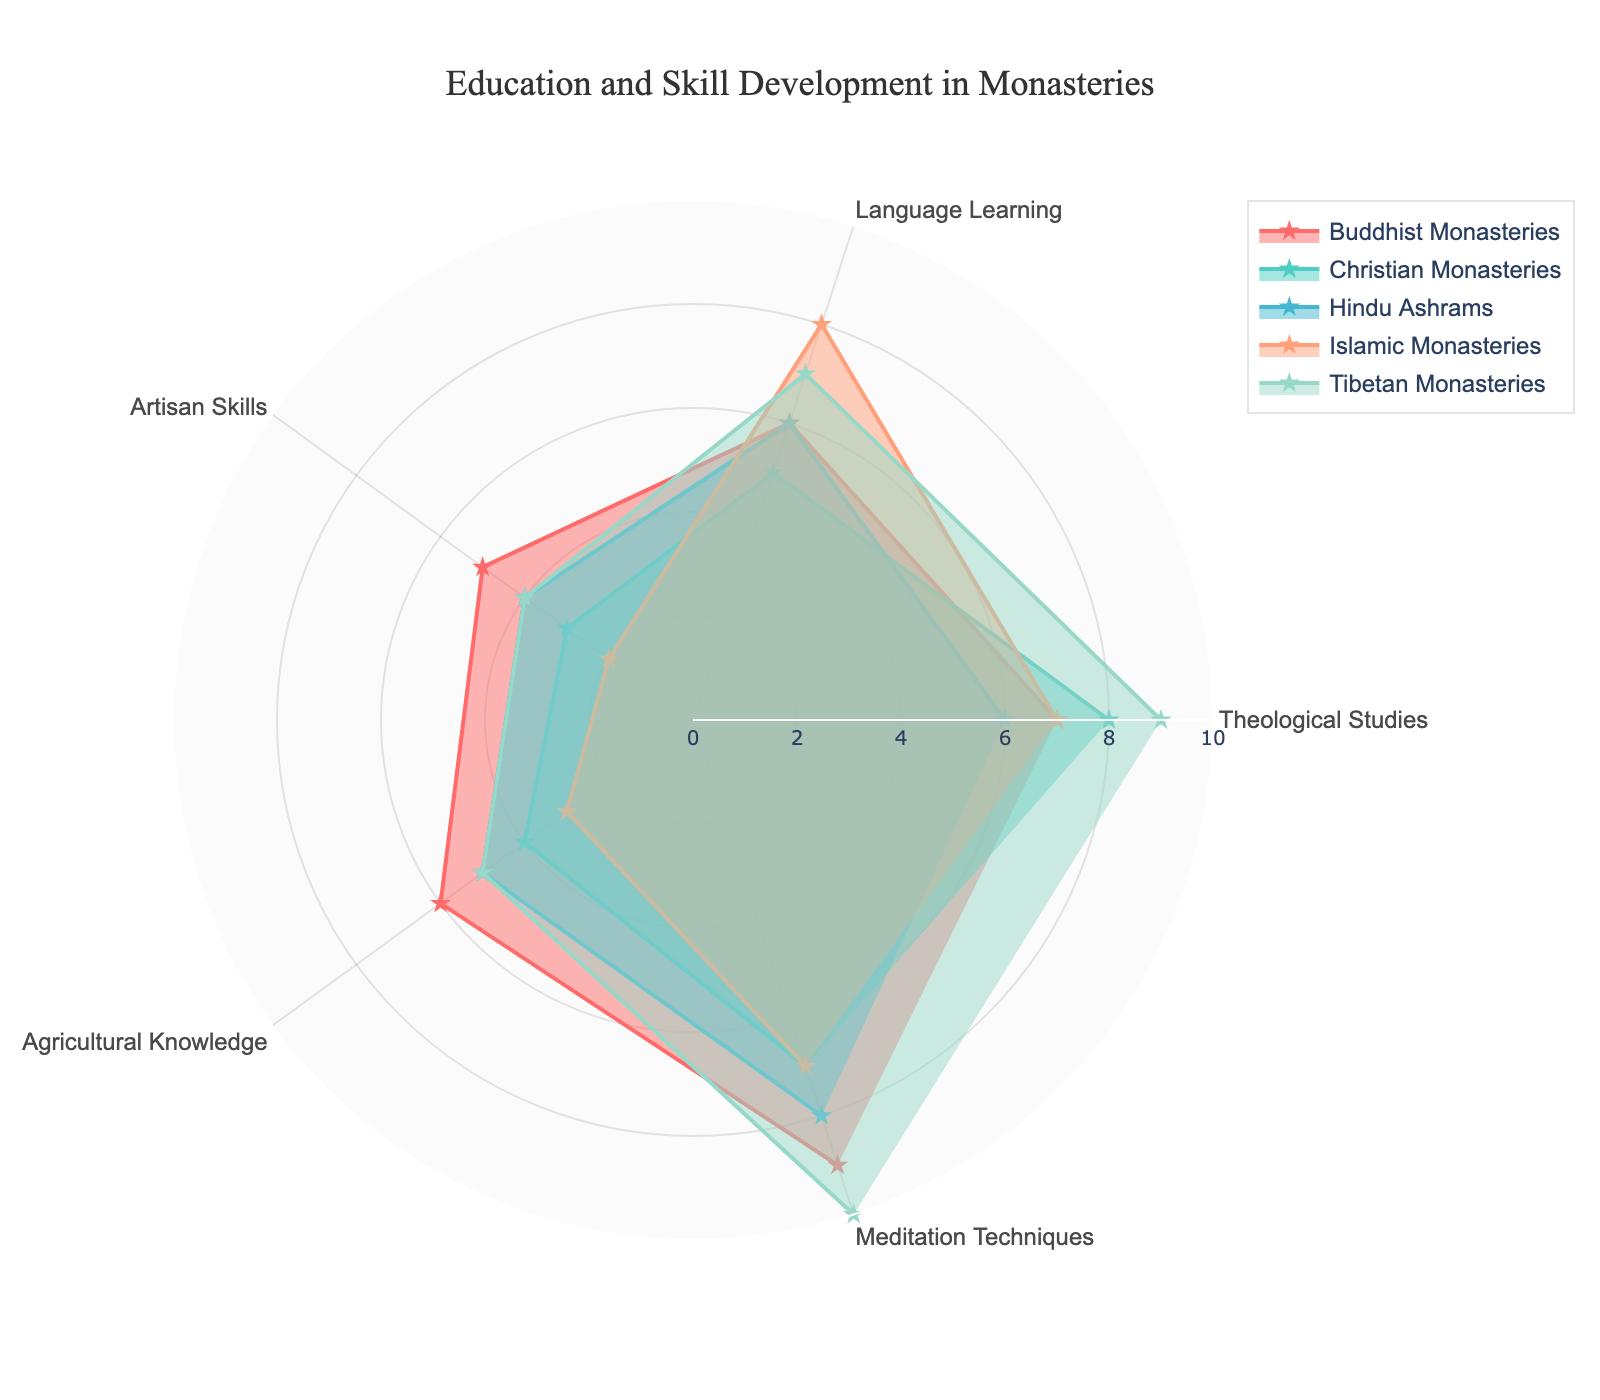What is the title of the radar chart? The title is normally displayed in the top center of the chart. In this figure, the title text is 'Education and Skill Development in Monasteries'.
Answer: Education and Skill Development in Monasteries Which monastery has the highest value in Meditation Techniques? Locate the category "Meditation Techniques" on the radar chart and find the corresponding maximum value. Tibetan Monasteries score the highest with a value of 10.
Answer: Tibetan Monasteries What is the average score of Language Learning across all monasteries? To compute the average, sum the language learning scores of all monasteries (6+5+6+8+7) and divide by the number of monasteries (5). This results in an average score of 6.4.
Answer: 6.4 Which education category has the most balanced scores across all monasteries? Look for the category where scores are relatively close in range across all monasteries. Agricultural Knowledge has scores of 6, 4, 5, 3, and 5, which vary less compared to other categories.
Answer: Agricultural Knowledge How does the score for Theological Studies in Christian Monasteries compare to Islamic Monasteries? Find the scores for Theological Studies for both Christian Monasteries and Islamic Monasteries. Christian has an 8, and Islamic has a 7. Christian Monasteries score higher by 1 point.
Answer: Christian Monasteries score higher by 1 point Which monastery has the lowest score in Artisan Skills and what is it? Locate the category "Artisan Skills" and identify the lowest scoring monastery. The lowest score of 2 is for Islamic Monasteries.
Answer: Islamic Monasteries with a score of 2 Is there any category where Christian Monasteries score higher than Buddhist Monasteries? Compare the scores of Christian and Buddhist Monasteries across each category. Christian Monasteries score higher in Theological Studies (8 vs. 7).
Answer: Yes, in Theological Studies Which monastery has the highest overall average score across all categories? Calculate the average score for each monastery and compare. Tibetan Monasteries have an average score of (9+7+4+5+10)/5 = 7, the highest among the monasteries.
Answer: Tibetan Monasteries Are there any monasteries that have the same score for all five categories? Check if any monastery has identical scores across the five categories. No monastery has the same score for all categories.
Answer: No How many different color lines are used in the radar chart? Count the number of uniquely colored lines in the radar chart. There are five different color lines corresponding to five monasteries.
Answer: Five 